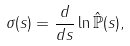<formula> <loc_0><loc_0><loc_500><loc_500>\sigma ( s ) = \frac { d } { d s } \ln \mathbb { \hat { P } } ( s ) ,</formula> 